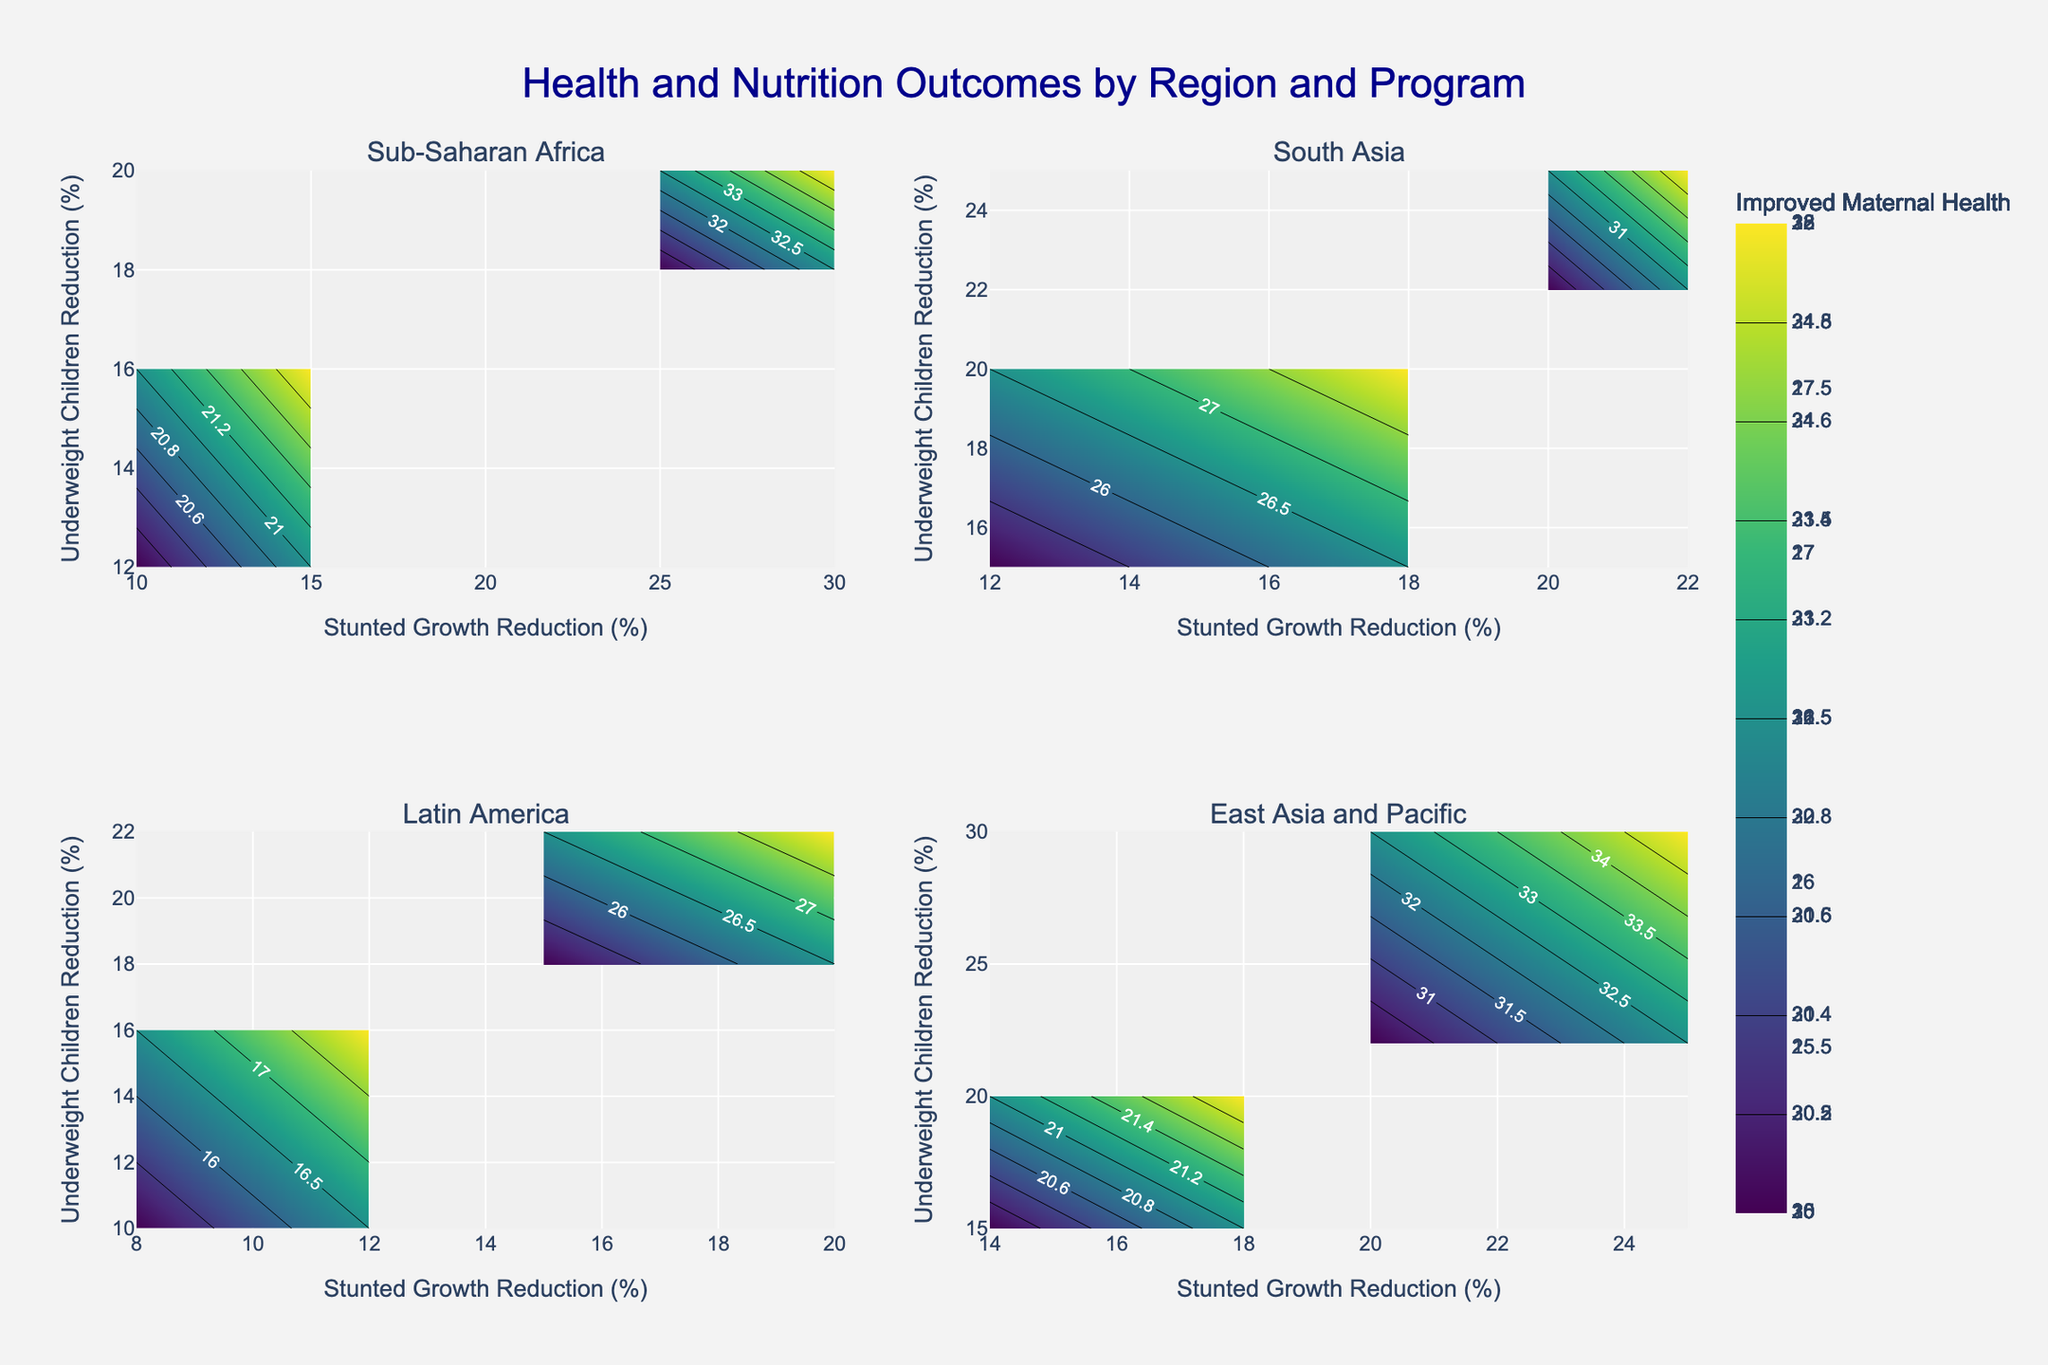Which region has the highest impact on maternal health improvement due to the Supplemental Feeding program? Looking at Sub-Saharan Africa's subplot, we can see that the Improved Maternal Health values for Supplemental Feeding are higher than other regions. The figures in Sub-Saharan Africa for this program are 30 in 2020 and 35 in 2021.
Answer: Sub-Saharan Africa What is the title of the figure? The title is mentioned at the top of the figure, summarizing what the plot represents.
Answer: Health and Nutrition Outcomes by Region and Program Which region shows the largest increase in stunted growth reduction for any single program from 2020 to 2021? For this, we check each subplot for the differences between 2020 and 2021. Sub-Saharan Africa Supplement Feeding shows an increase from 25% to 30%, which is the largest compared to the other regions and programs.
Answer: Sub-Saharan Africa How are the axes labeled in the plot? Both x and y axes are labeled consistently across all subplots. The x-axis represents "Stunted Growth Reduction (%)" and the y-axis indicates "Underweight Children Reduction (%)".
Answer: Stunted Growth Reduction (%), Underweight Children Reduction (%) Which region and program combination has the highest reduction in underweight children? By observing all the subplots, it is seen that Sub-Saharan Africa with Supplemental Feeding in 2021 has the highest value for Underweight Children Reduction at 20%.
Answer: Sub-Saharan Africa, Supplemental Feeding Compare the reduction in underweight children for Immunization Programs between 2020 and 2021 in South Asia. In South Asia's subplot, the contour for Immunization Programs shows values for Underweight Children Reduction going from 22 in 2020 to 25 in 2021.
Answer: 2021 is higher What color scale is used for representing the contours? The contours in all subplots use the 'Viridis' color scale, which varies through shades of green to yellow.
Answer: Viridis In which region did Nutrition Counseling show improvement in maternal health between 2020 and 2021? In the subplot for East Asia and Pacific, the contour for Nutrition Counseling shows an increase in Improved Maternal Health from 20 in 2020 to 22 in 2021.
Answer: East Asia and Pacific 